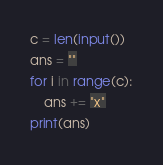<code> <loc_0><loc_0><loc_500><loc_500><_Python_>c = len(input())
ans = ""
for i in range(c):
    ans += "x"
print(ans)</code> 